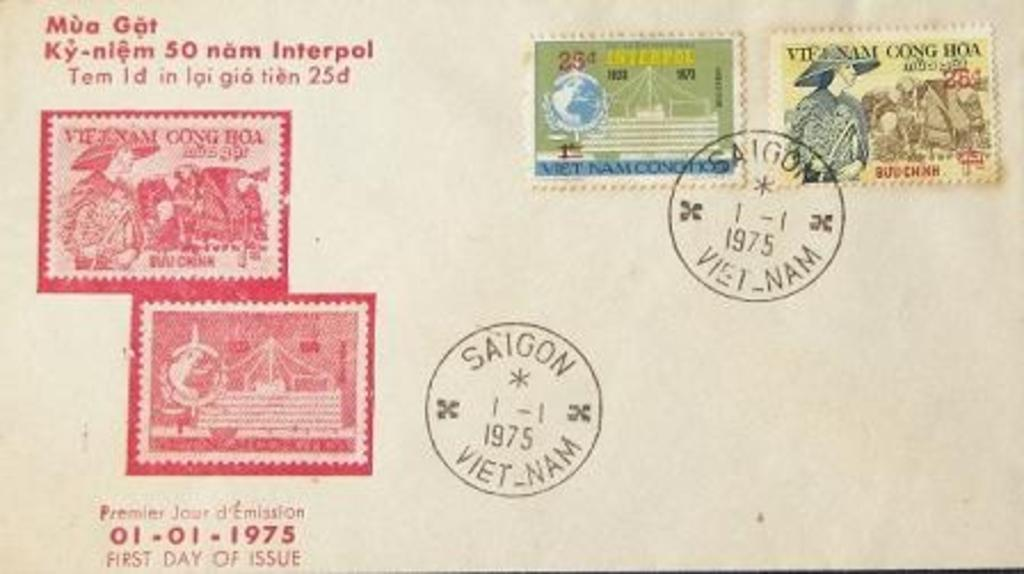<image>
Render a clear and concise summary of the photo. a post card with stamps from Saigon Vietnam 1975 